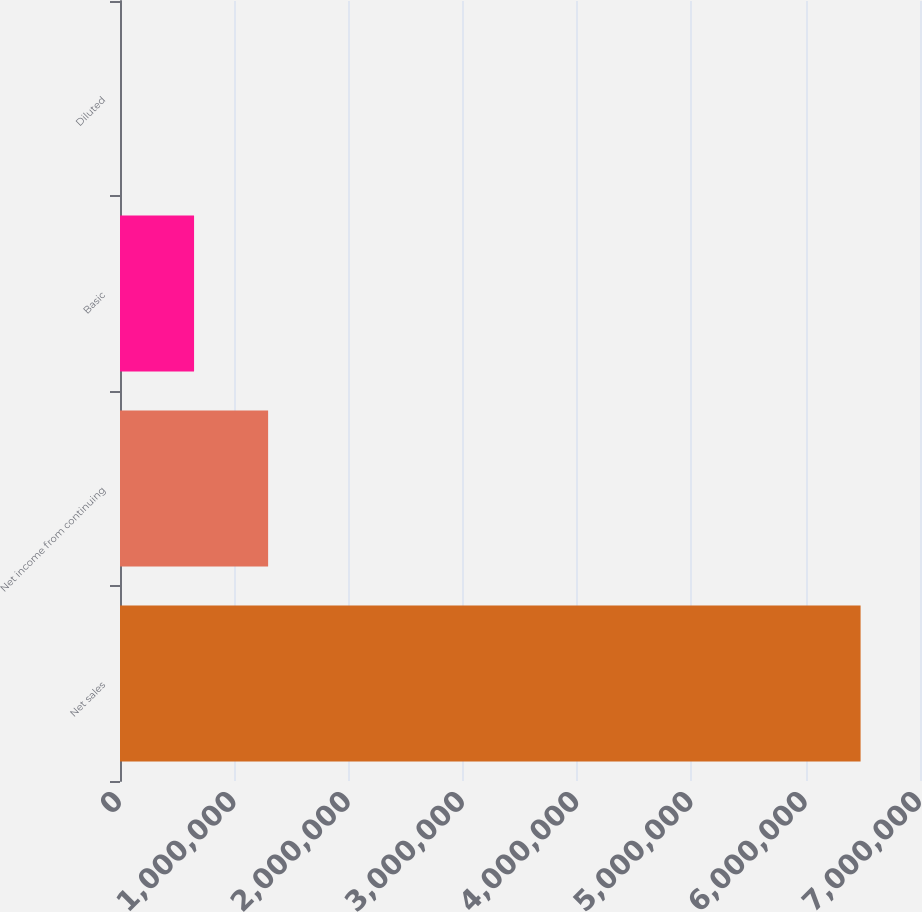Convert chart to OTSL. <chart><loc_0><loc_0><loc_500><loc_500><bar_chart><fcel>Net sales<fcel>Net income from continuing<fcel>Basic<fcel>Diluted<nl><fcel>6.48015e+06<fcel>1.29603e+06<fcel>648016<fcel>1.08<nl></chart> 